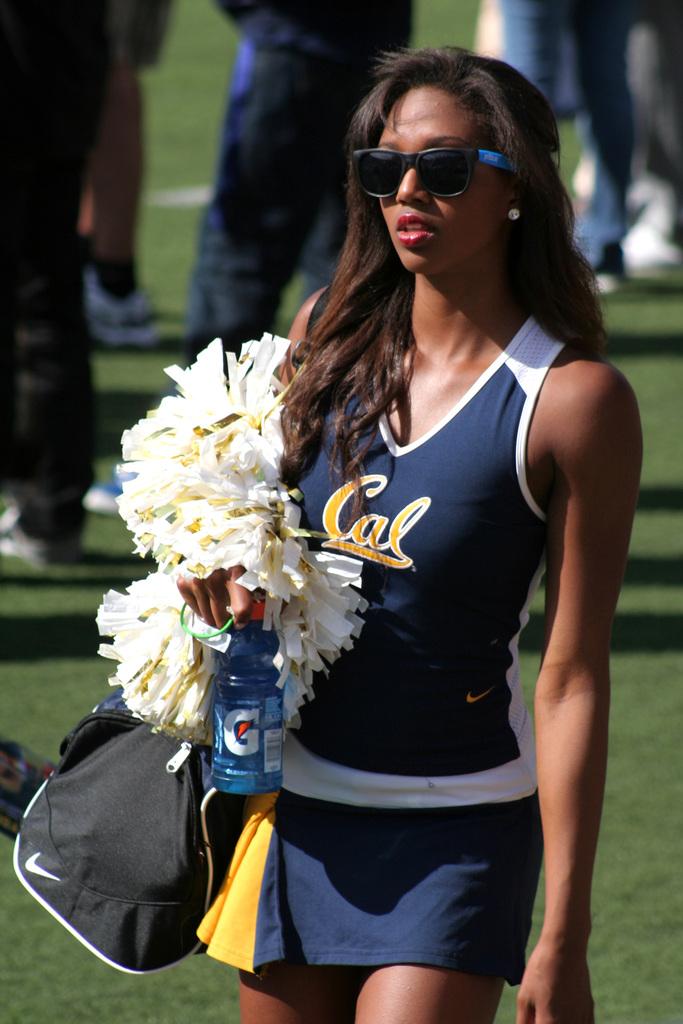What letter is on her drink bottle?
Ensure brevity in your answer.  G. 